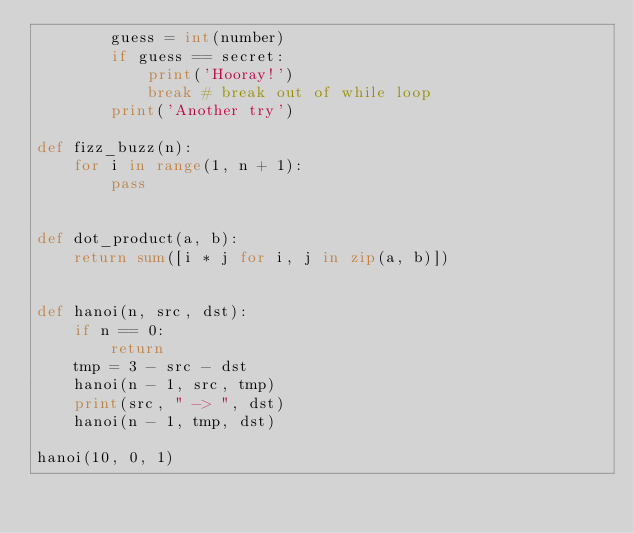Convert code to text. <code><loc_0><loc_0><loc_500><loc_500><_Python_>        guess = int(number)
        if guess == secret:
            print('Hooray!')
            break # break out of while loop
        print('Another try')

def fizz_buzz(n):
    for i in range(1, n + 1):
        pass


def dot_product(a, b):
    return sum([i * j for i, j in zip(a, b)])


def hanoi(n, src, dst):
    if n == 0:
        return
    tmp = 3 - src - dst
    hanoi(n - 1, src, tmp)
    print(src, " -> ", dst)
    hanoi(n - 1, tmp, dst)

hanoi(10, 0, 1)
</code> 